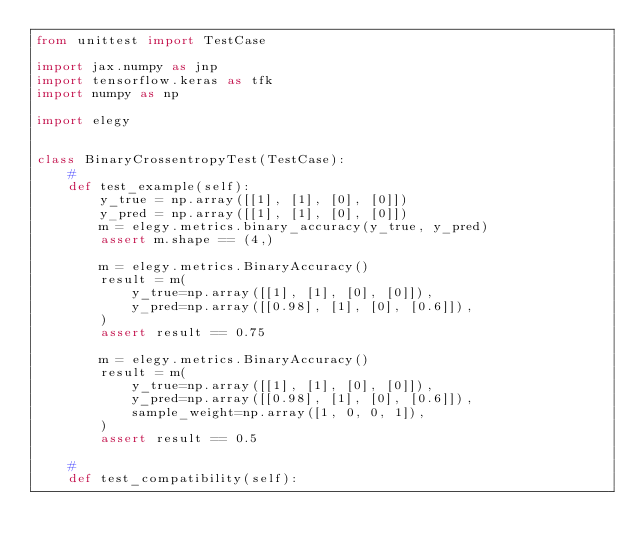Convert code to text. <code><loc_0><loc_0><loc_500><loc_500><_Python_>from unittest import TestCase

import jax.numpy as jnp
import tensorflow.keras as tfk
import numpy as np

import elegy


class BinaryCrossentropyTest(TestCase):
    #
    def test_example(self):
        y_true = np.array([[1], [1], [0], [0]])
        y_pred = np.array([[1], [1], [0], [0]])
        m = elegy.metrics.binary_accuracy(y_true, y_pred)
        assert m.shape == (4,)

        m = elegy.metrics.BinaryAccuracy()
        result = m(
            y_true=np.array([[1], [1], [0], [0]]),
            y_pred=np.array([[0.98], [1], [0], [0.6]]),
        )
        assert result == 0.75

        m = elegy.metrics.BinaryAccuracy()
        result = m(
            y_true=np.array([[1], [1], [0], [0]]),
            y_pred=np.array([[0.98], [1], [0], [0.6]]),
            sample_weight=np.array([1, 0, 0, 1]),
        )
        assert result == 0.5

    #
    def test_compatibility(self):
</code> 